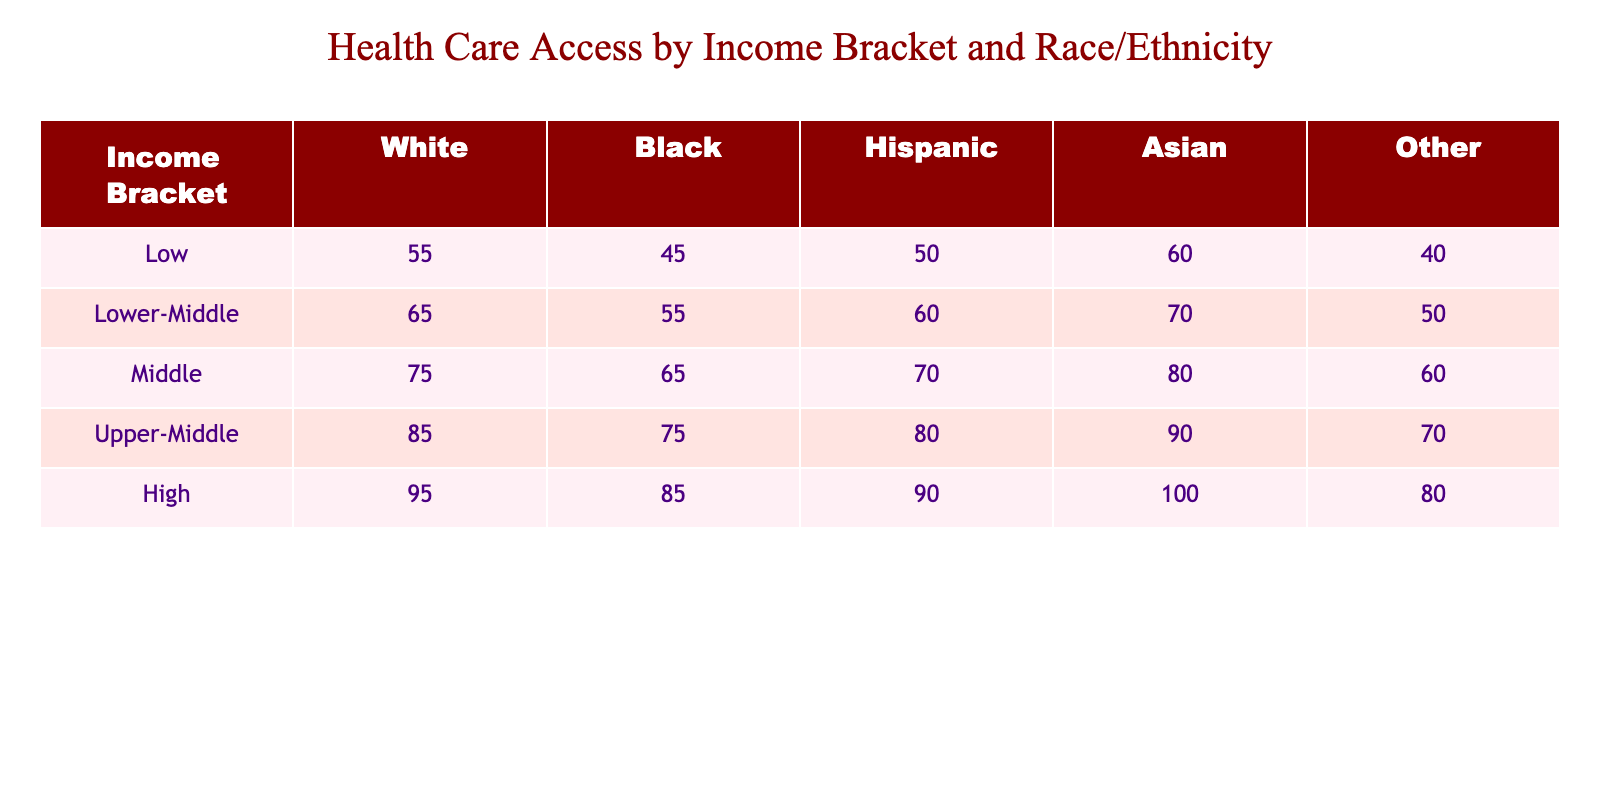What is the health care access percentage for Black individuals in the Upper-Middle income bracket? According to the table, the health care access percentage for Black individuals in the Upper-Middle income bracket is 75.
Answer: 75 What is the health care access percentage for Hispanic individuals in the Middle income bracket? The table shows that the health care access percentage for Hispanic individuals in the Middle income bracket is 70.
Answer: 70 What is the total health care access percentage for individuals in the Low-income bracket? To find the total, we can sum the percentages for all racial/ethnic groups in that bracket: 55 (White) + 45 (Black) + 50 (Hispanic) + 60 (Asian) + 40 (Other) = 250.
Answer: 250 Is the health care access percentage for Asian individuals in the High-income bracket higher than that for White individuals in the same bracket? The health care access percentage for Asian individuals in the High-income bracket is 100, which is higher than the percentage for White individuals in that bracket, which is 95.
Answer: Yes What is the average health care access percentage for all racial/ethnic groups in the Lower-Middle income bracket? For the Lower-Middle income bracket, the percentages are: 65 (White), 55 (Black), 60 (Hispanic), 70 (Asian), and 50 (Other). To find the average, we sum them: 65 + 55 + 60 + 70 + 50 = 300, and divide by the number of groups: 300 / 5 = 60.
Answer: 60 Which income bracket has the highest health care access percentage for Other individuals? By checking the table, the highest percentage for Other individuals is in the High-income bracket, where it is 80.
Answer: 80 What is the difference in health care access percentages between White individuals in the Upper-Middle and Lower-Middle income brackets? The percentage for White individuals in the Upper-Middle bracket is 85, and in the Lower-Middle bracket it is 65. The difference is: 85 - 65 = 20.
Answer: 20 Which racial/ethnic group has the lowest health care access percentage in the Low-income bracket? In the Low-income bracket, the percentages are: 55 (White), 45 (Black), 50 (Hispanic), 60 (Asian), and 40 (Other). The lowest percentage is for Other individuals at 40.
Answer: Other What is the combined health care access percentage for Black and Hispanic individuals in the Middle income bracket? For these two groups in the Middle income bracket, the percentages are 65 (Black) and 70 (Hispanic). Combined, that is 65 + 70 = 135.
Answer: 135 